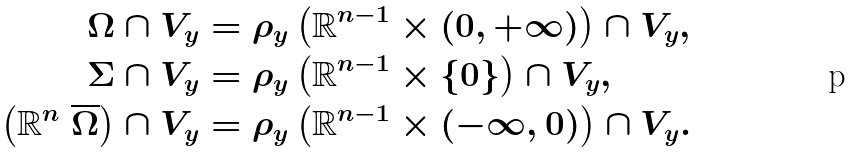Convert formula to latex. <formula><loc_0><loc_0><loc_500><loc_500>\Omega \cap V _ { y } & = \rho _ { y } \left ( { \mathbb { R } } ^ { n - 1 } \times ( 0 , + \infty ) \right ) \cap V _ { y } , \\ \Sigma \cap V _ { y } & = \rho _ { y } \left ( { \mathbb { R } } ^ { n - 1 } \times \{ 0 \} \right ) \cap V _ { y } , \\ \left ( { \mathbb { R } } ^ { n } \ \overline { \Omega } \right ) \cap V _ { y } & = \rho _ { y } \left ( { \mathbb { R } } ^ { n - 1 } \times ( - \infty , 0 ) \right ) \cap V _ { y } .</formula> 